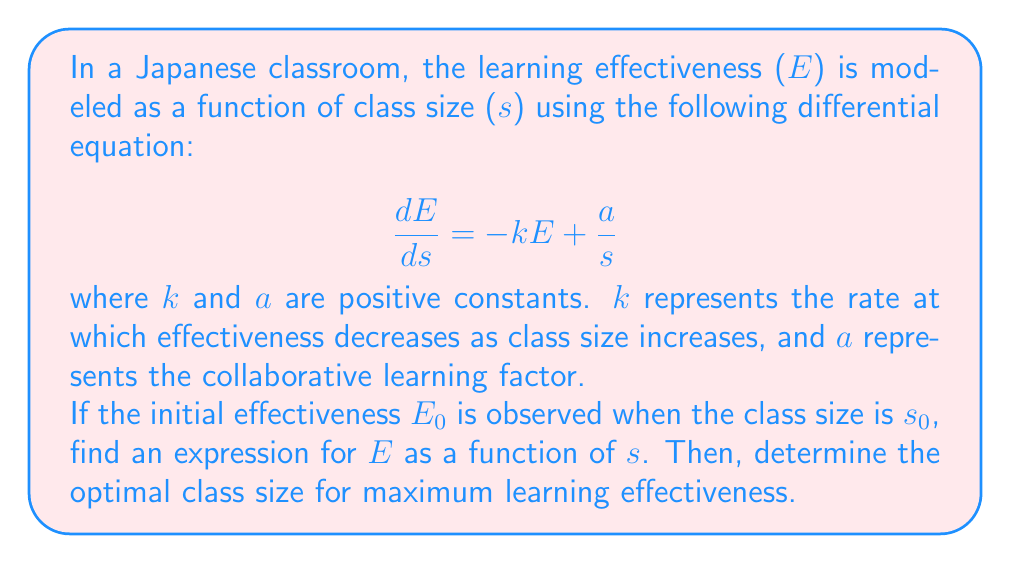What is the answer to this math problem? To solve this problem, we'll follow these steps:

1) First, we need to solve the differential equation. This is a first-order linear differential equation.

2) The general solution for this type of equation is:

   $$E = e^{-\int P(s)ds}(\int Q(s)e^{\int P(s)ds}ds + C)$$

   where $P(s) = k$ and $Q(s) = \frac{a}{s}$

3) Solving the integrals:

   $$\int P(s)ds = \int k ds = ks$$
   $$e^{\int P(s)ds} = e^{ks}$$

4) Now, let's solve the right part of the equation:

   $$\int Q(s)e^{\int P(s)ds}ds = \int \frac{a}{s}e^{ks}ds$$

   This integral can be solved using integration by parts. Let $u = e^{ks}$ and $dv = \frac{a}{s}ds$. Then:

   $$\int \frac{a}{s}e^{ks}ds = \frac{a}{k}e^{ks}\ln(s) - \frac{a}{k}\int e^{ks}d(\ln(s))$$
   $$= \frac{a}{k}e^{ks}\ln(s) - \frac{a}{k}\int e^{ks}\frac{1}{s}ds$$

   The last integral is the same as what we started with, so we can write:

   $$\int \frac{a}{s}e^{ks}ds = \frac{a}{k}e^{ks}\ln(s) - \frac{a}{k}\int \frac{a}{s}e^{ks}ds$$

   Solving for the integral:

   $$\int \frac{a}{s}e^{ks}ds = \frac{a}{k}e^{ks}\ln(s) - \frac{a}{k}\int \frac{a}{s}e^{ks}ds$$
   $$2\int \frac{a}{s}e^{ks}ds = \frac{a}{k}e^{ks}\ln(s)$$
   $$\int \frac{a}{s}e^{ks}ds = \frac{a}{2k}e^{ks}\ln(s)$$

5) Putting it all together:

   $$E = e^{-ks}(\frac{a}{2k}e^{ks}\ln(s) + C)$$
   $$E = \frac{a}{2k}\ln(s) + Ce^{-ks}$$

6) To find C, we use the initial condition: when $s = s_0$, $E = E_0$

   $$E_0 = \frac{a}{2k}\ln(s_0) + Ce^{-ks_0}$$
   $$C = (E_0 - \frac{a}{2k}\ln(s_0))e^{ks_0}$$

7) Therefore, the final solution is:

   $$E = \frac{a}{2k}\ln(s) + (E_0 - \frac{a}{2k}\ln(s_0))e^{k(s_0-s)}$$

8) To find the optimal class size, we need to find the maximum of this function. We can do this by differentiating E with respect to s and setting it to zero:

   $$\frac{dE}{ds} = \frac{a}{2ks} - k(E_0 - \frac{a}{2k}\ln(s_0))e^{k(s_0-s)} = 0$$

9) Solving this equation:

   $$\frac{a}{2ks} = k(E_0 - \frac{a}{2k}\ln(s_0))e^{k(s_0-s)}$$
   $$\frac{a}{2k^2s} = (E_0 - \frac{a}{2k}\ln(s_0))e^{k(s_0-s)}$$

   The optimal class size $s_{opt}$ satisfies this equation.
Answer: The expression for E as a function of s is:

$$E = \frac{a}{2k}\ln(s) + (E_0 - \frac{a}{2k}\ln(s_0))e^{k(s_0-s)}$$

The optimal class size $s_{opt}$ satisfies the equation:

$$\frac{a}{2k^2s_{opt}} = (E_0 - \frac{a}{2k}\ln(s_0))e^{k(s_0-s_{opt})}$$ 